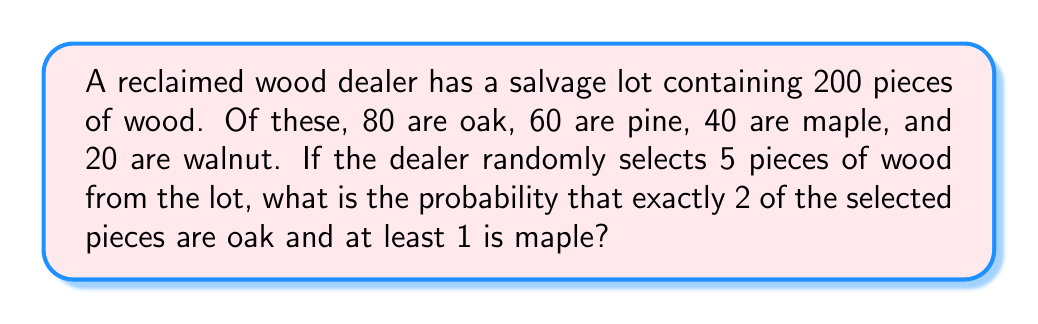Help me with this question. Let's approach this step-by-step using the concepts of combinatorics and probability:

1) First, we need to calculate the probability of selecting exactly 2 oak pieces and at least 1 maple piece out of 5 selections.

2) We can break this down into two scenarios:
   a) 2 oak, 1 maple, 2 other
   b) 2 oak, 2 maple, 1 other

3) Let's calculate the probability for scenario a:
   - Ways to choose 2 oak out of 80: $\binom{80}{2}$
   - Ways to choose 1 maple out of 40: $\binom{40}{1}$
   - Ways to choose 2 other out of 80 (60 pine + 20 walnut): $\binom{80}{2}$
   - Total ways for this scenario: $\binom{80}{2} \cdot \binom{40}{1} \cdot \binom{80}{2}$

4) Now for scenario b:
   - Ways to choose 2 oak out of 80: $\binom{80}{2}$
   - Ways to choose 2 maple out of 40: $\binom{40}{2}$
   - Ways to choose 1 other out of 80: $\binom{80}{1}$
   - Total ways for this scenario: $\binom{80}{2} \cdot \binom{40}{2} \cdot \binom{80}{1}$

5) Total favorable outcomes = Scenario a + Scenario b

6) Total possible outcomes when selecting 5 pieces out of 200: $\binom{200}{5}$

7) Therefore, the probability is:

   $$P = \frac{\binom{80}{2} \cdot \binom{40}{1} \cdot \binom{80}{2} + \binom{80}{2} \cdot \binom{40}{2} \cdot \binom{80}{1}}{\binom{200}{5}}$$

8) Calculating this:
   $$P = \frac{3160 \cdot 40 \cdot 3160 + 3160 \cdot 780 \cdot 80}{2,535,650,800} \approx 0.0392$$
Answer: $\frac{99,532,800}{2,535,650,800} \approx 0.0392$ 